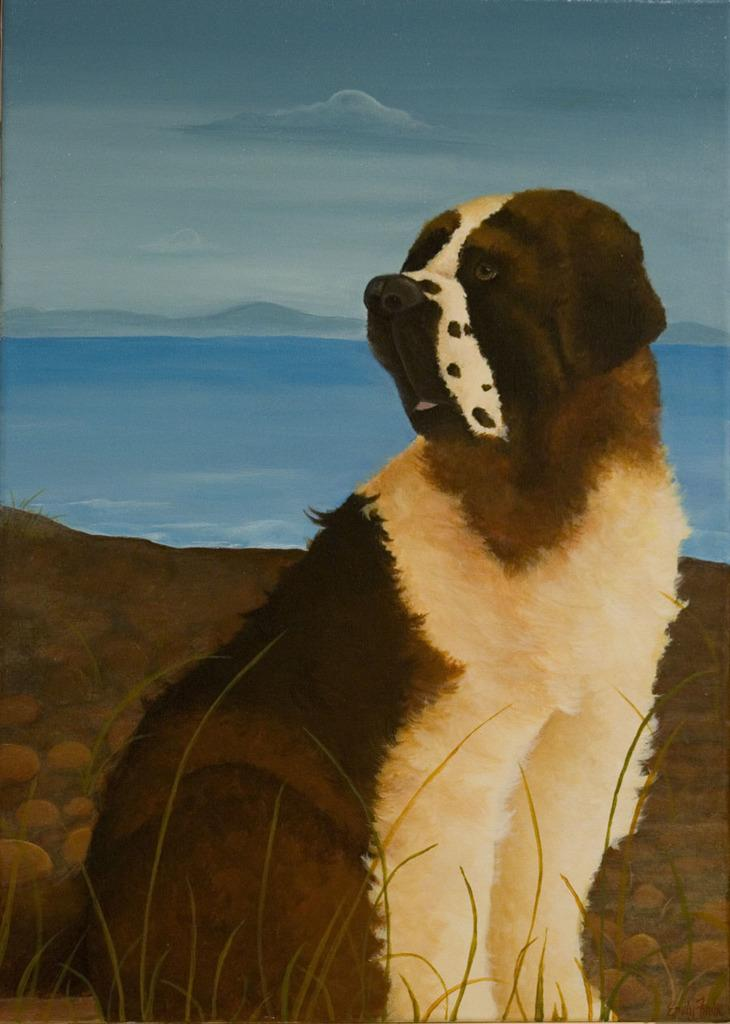What type of picture is the image? The image is an animated picture. What can be seen in the background of the image? There is a sky and water visible in the background of the image. What animal is present in the image? There is a dog in the image. What type of terrain is depicted in the image? There are stones and grass in the image. What type of advice is the dog giving to the ghost in the image? There is no ghost present in the image, and therefore no advice can be given. 